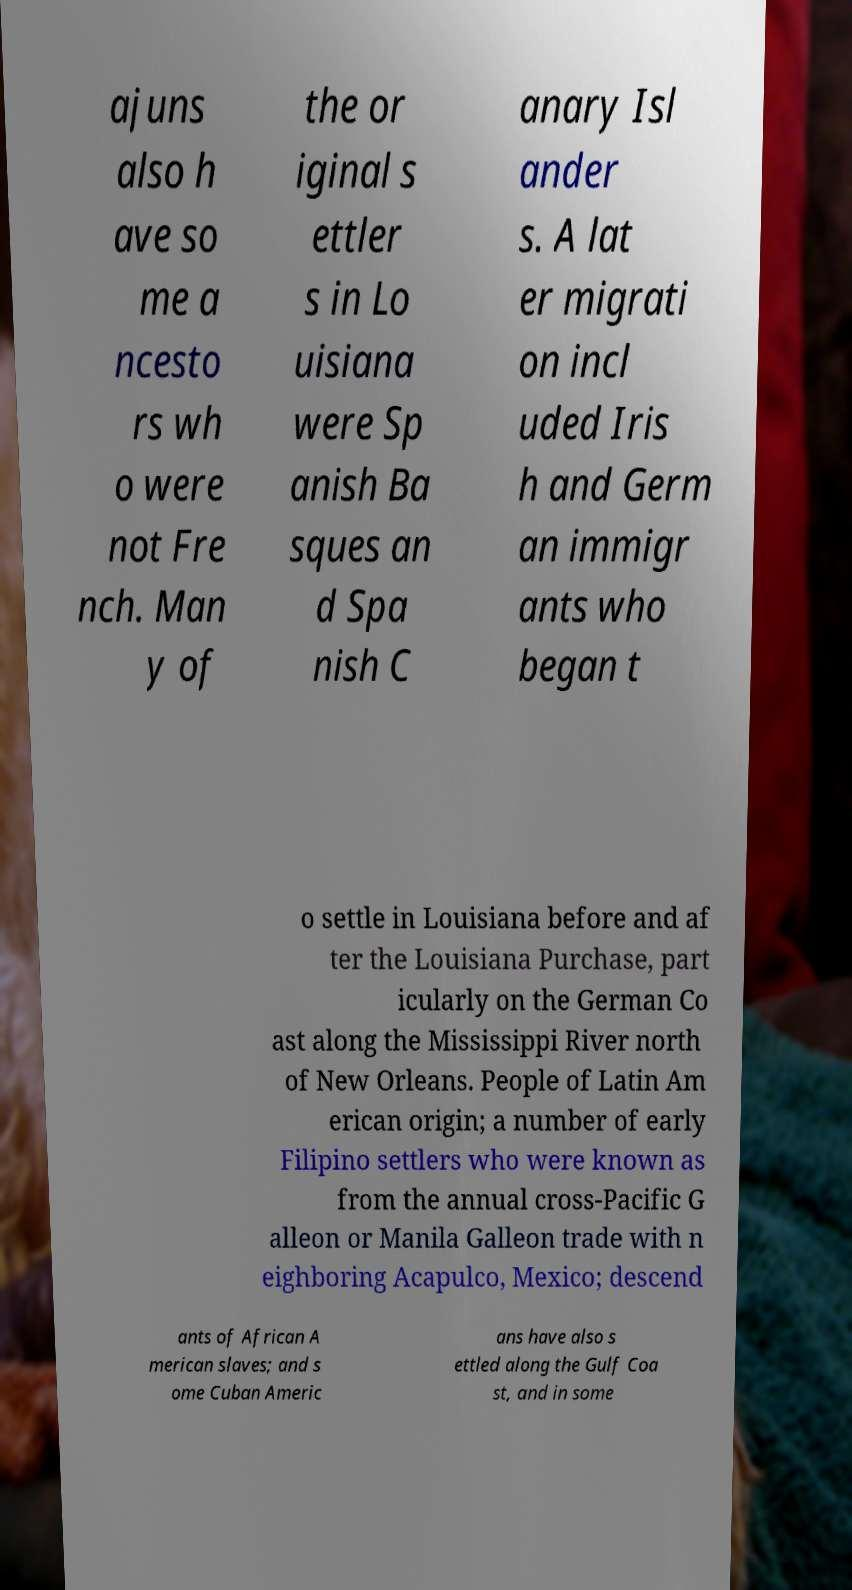For documentation purposes, I need the text within this image transcribed. Could you provide that? ajuns also h ave so me a ncesto rs wh o were not Fre nch. Man y of the or iginal s ettler s in Lo uisiana were Sp anish Ba sques an d Spa nish C anary Isl ander s. A lat er migrati on incl uded Iris h and Germ an immigr ants who began t o settle in Louisiana before and af ter the Louisiana Purchase, part icularly on the German Co ast along the Mississippi River north of New Orleans. People of Latin Am erican origin; a number of early Filipino settlers who were known as from the annual cross-Pacific G alleon or Manila Galleon trade with n eighboring Acapulco, Mexico; descend ants of African A merican slaves; and s ome Cuban Americ ans have also s ettled along the Gulf Coa st, and in some 